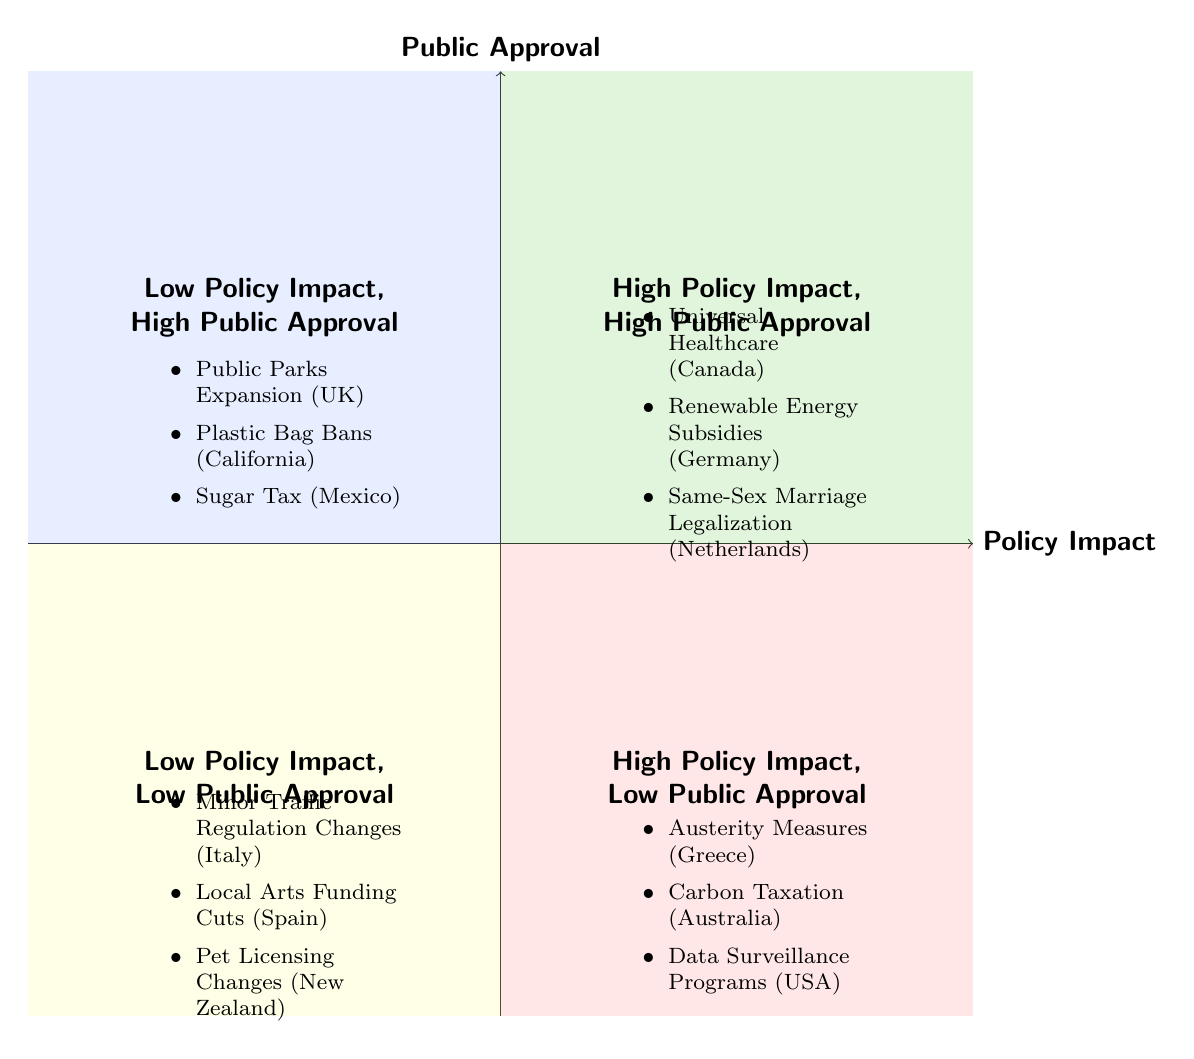What examples are in the "High Policy Impact, High Public Approval" quadrant? The "High Policy Impact, High Public Approval" quadrant contains examples that show both a significant positive effect from policy implementation and high levels of public support. The data provided lists three examples: Universal Healthcare Implementation in Canada, Renewable Energy Subsidies in Germany, and Same-Sex Marriage Legalization in the Netherlands.
Answer: Universal Healthcare Implementation in Canada, Renewable Energy Subsidies in Germany, Same-Sex Marriage Legalization in the Netherlands Which quadrant contains "Carbon Taxation in Australia"? "Carbon Taxation in Australia" is mentioned in the quadrant labeled "High Policy Impact, Low Public Approval." This quadrant is identified by policies that have a substantial impact but face criticism or low approval from the public.
Answer: High Policy Impact, Low Public Approval How many examples are listed under "Low Policy Impact, Low Public Approval"? In the "Low Policy Impact, Low Public Approval" quadrant, three specific examples are provided: Minor Traffic Regulation Changes in Italy, Local Arts Funding Cuts in Spain, and Pet Licensing Changes in New Zealand. This means the count of examples listed is three.
Answer: 3 What is the primary characteristic of policies in the "Low Policy Impact, High Public Approval" quadrant? The primary characteristic of the "Low Policy Impact, High Public Approval" quadrant is that these policies have a minor effect on the target issue while enjoying high acceptance or approval from the public. For instance, Public Parks Expansion in the UK is an example of such a policy.
Answer: Minor impact with high approval Which quadrant has a combination of high policy impact and low public approval? The quadrant that represents a combination of high policy impact and low public approval is identified as "High Policy Impact, Low Public Approval." This quadrant illustrates policies that are effective but face significant public resistance or discontent.
Answer: High Policy Impact, Low Public Approval What examples indicate effective policies in an unpopular space? The examples indicating effective policies that are unpopular are found in the "High Policy Impact, Low Public Approval" quadrant. For instance, Austerity Measures in Greece, Carbon Taxation in Australia, and Data Surveillance Programs in the USA are cited here, reflecting policies that have substantial impacts yet low public support.
Answer: Austerity Measures in Greece, Carbon Taxation in Australia, Data Surveillance Programs in the USA 